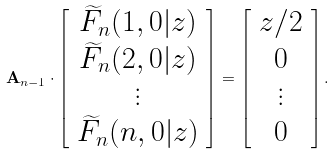Convert formula to latex. <formula><loc_0><loc_0><loc_500><loc_500>\mathbf A _ { n - 1 } \cdot \left [ \begin{array} { c } \widetilde { F } _ { n } ( 1 , 0 | z ) \\ \widetilde { F } _ { n } ( 2 , 0 | z ) \\ \vdots \\ \widetilde { F } _ { n } ( n , 0 | z ) \\ \end{array} \right ] = \left [ \begin{array} { c } z / 2 \\ 0 \\ \vdots \\ 0 \\ \end{array} \right ] .</formula> 